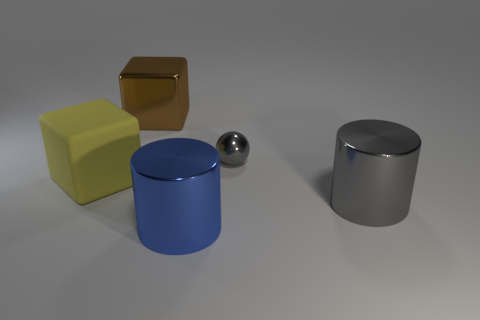Is there any other thing that is the same material as the large yellow object?
Keep it short and to the point. No. There is a tiny metallic sphere; are there any cylinders in front of it?
Give a very brief answer. Yes. What size is the gray object that is the same material as the gray sphere?
Make the answer very short. Large. How many large gray objects are the same shape as the large brown metal object?
Your answer should be compact. 0. Is the material of the brown thing the same as the big object that is on the left side of the large brown cube?
Provide a succinct answer. No. Is the number of large things to the right of the blue metallic cylinder greater than the number of brown rubber objects?
Give a very brief answer. Yes. What is the shape of the metal object that is the same color as the tiny metallic ball?
Your answer should be very brief. Cylinder. Is there a large cylinder that has the same material as the small thing?
Ensure brevity in your answer.  Yes. Do the big cylinder that is in front of the big gray shiny thing and the large yellow object that is behind the blue metal cylinder have the same material?
Ensure brevity in your answer.  No. Is the number of blue objects behind the brown cube the same as the number of big gray metallic objects right of the tiny gray object?
Offer a terse response. No. 